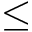Convert formula to latex. <formula><loc_0><loc_0><loc_500><loc_500>\leq</formula> 